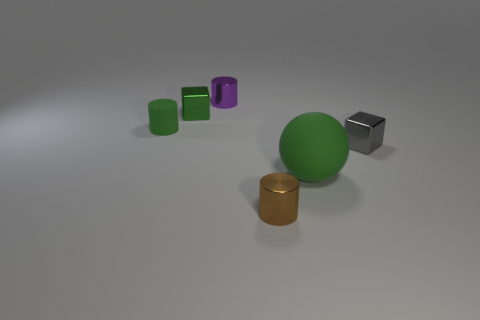Add 3 large yellow balls. How many objects exist? 9 Subtract all blocks. How many objects are left? 4 Subtract 1 purple cylinders. How many objects are left? 5 Subtract all small gray rubber cylinders. Subtract all tiny purple cylinders. How many objects are left? 5 Add 2 gray metal objects. How many gray metal objects are left? 3 Add 4 small brown shiny blocks. How many small brown shiny blocks exist? 4 